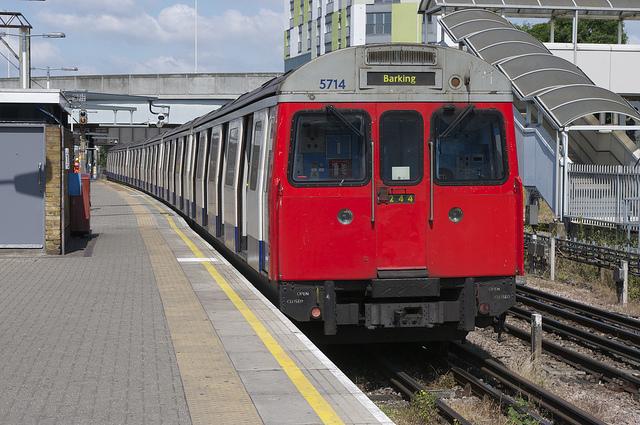Is the train coming or going?
Short answer required. Coming. What is the main color of the train?
Be succinct. Red. Does the train appear to be in working order?
Quick response, please. Yes. What number is on the train?
Short answer required. 5714. What number is the train?
Give a very brief answer. 5714. How many lights are lit on the front of the train?
Write a very short answer. 0. Is the train near the platform?
Give a very brief answer. Yes. What are the numbers in blue?
Write a very short answer. 5714. What color is the front part of the train?
Short answer required. Red. What rail line is this?
Keep it brief. Barking. What is in the picture?
Answer briefly. Train. 